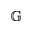<formula> <loc_0><loc_0><loc_500><loc_500>\mathbb { G }</formula> 